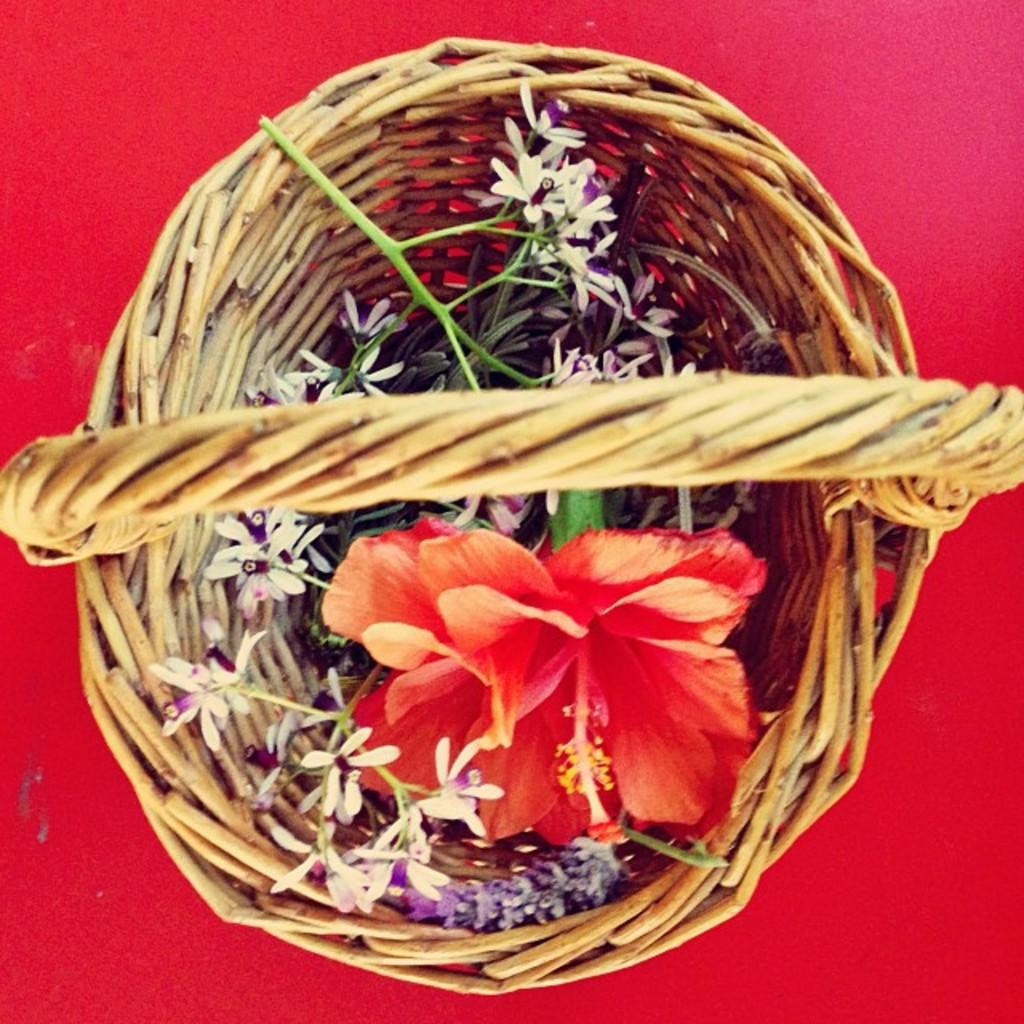What objects are present in the image? There are baskets in the image. What are the baskets holding? There are flowers in the baskets. How many feet are visible in the image? There are no feet visible in the image; it only features baskets with flowers. How many brothers are present in the image? There are no brothers present in the image; it only features baskets with flowers. 